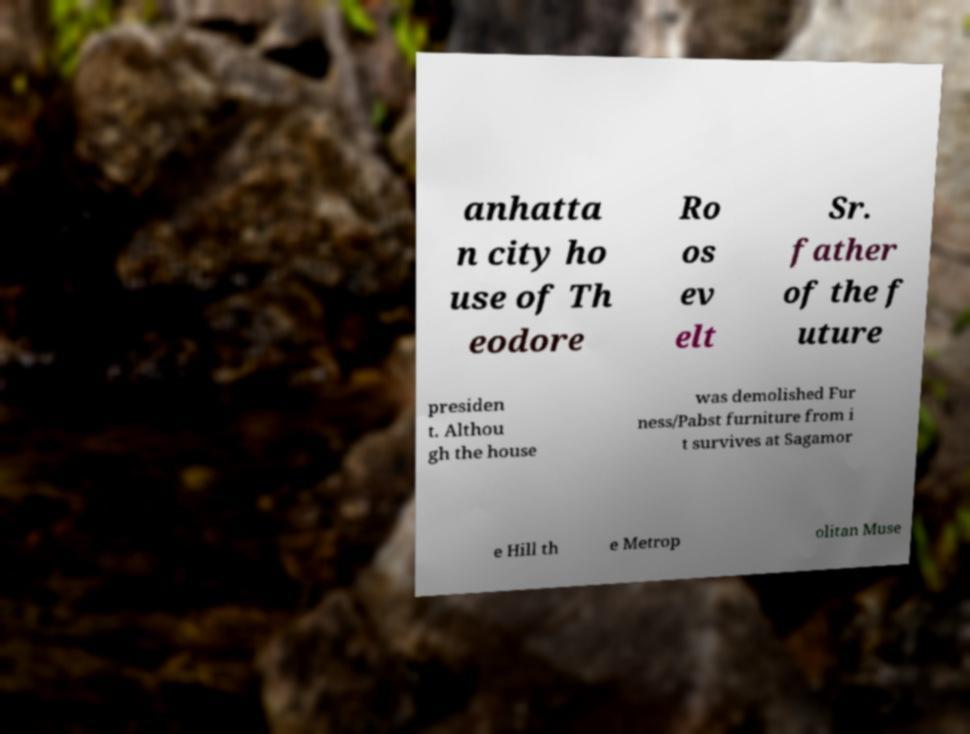Could you extract and type out the text from this image? anhatta n city ho use of Th eodore Ro os ev elt Sr. father of the f uture presiden t. Althou gh the house was demolished Fur ness/Pabst furniture from i t survives at Sagamor e Hill th e Metrop olitan Muse 